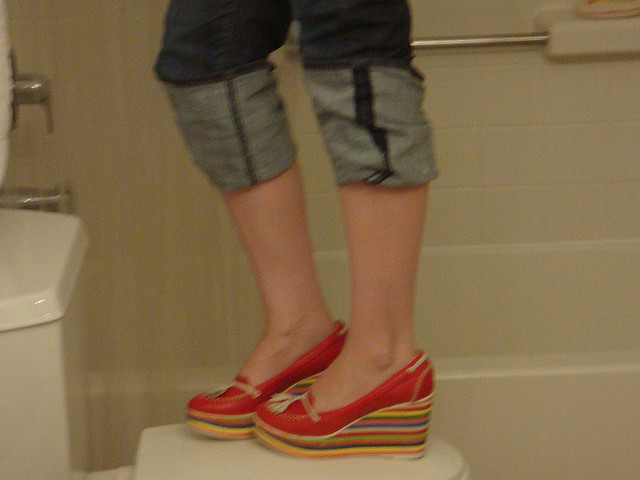<image>What is she preparing to make? I don't know what she is preparing to make. It can be bulb change or going out in new shoes. What is she preparing to make? I am not sure what she is preparing to make. It can be nothing, pictures, bulb change, step, light or go out in new shoes. 